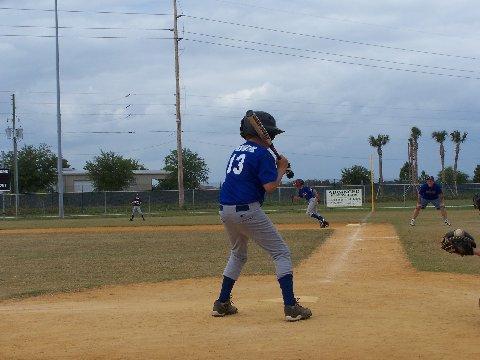How many people are there?
Give a very brief answer. 1. How many chairs are under the wood board?
Give a very brief answer. 0. 